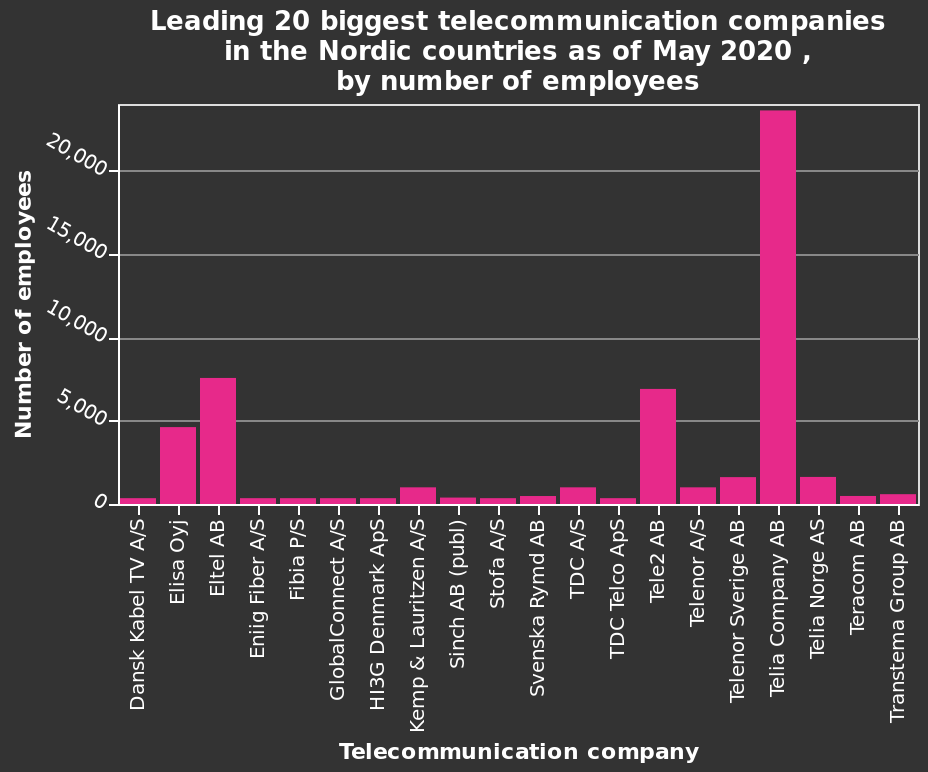<image>
What is the size range of the smallest companies mentioned in the figure?  The smallest companies have less than 1000 employees. Which telecommunication company has the highest number of employees in the Nordic countries as of May 2020?  The telecommunication company with the highest number of employees in the Nordic countries as of May 2020 is unknown, as it is not specified in the given information. How many employees does Teila Company AB have?  Teila Company AB has between 20,000 and 25,000 employees. Can you provide the name of the telecommunication company with the lowest number of employees in the Nordic countries as of May 2020?  The name of the telecommunication company with the lowest number of employees in the Nordic countries as of May 2020 is unknown, as it is not specified in the given information. Which Nordic country has the highest number of telecommunication companies listed on the chart?  The Nordic country with the highest number of telecommunication companies listed on the chart is unknown, as it is not specified in the given information. What is the majority type of companies shown in the figure? The majority of the companies shown have less than 1000 employees. Is the number of employees represented on the y-axis of the bar chart?  Yes, the number of employees is represented on the y-axis of the bar chart. 